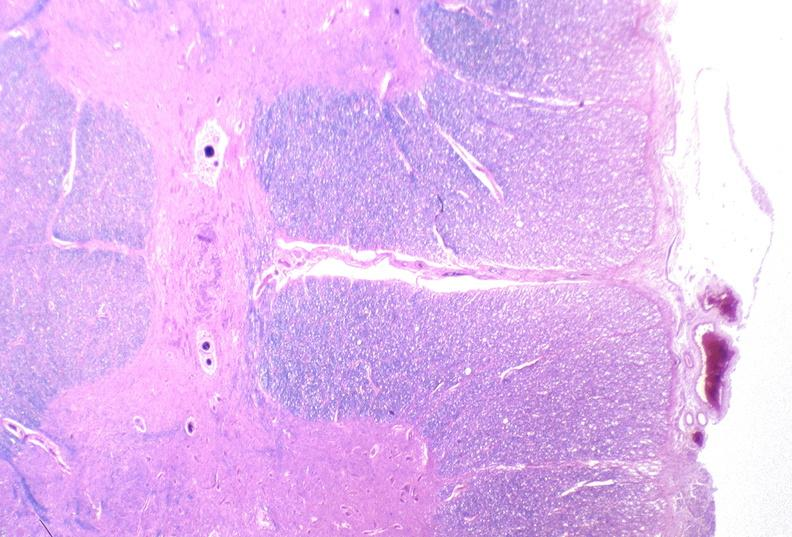does this image show spinal cord injury due to vertebral column trauma, demyelination?
Answer the question using a single word or phrase. Yes 